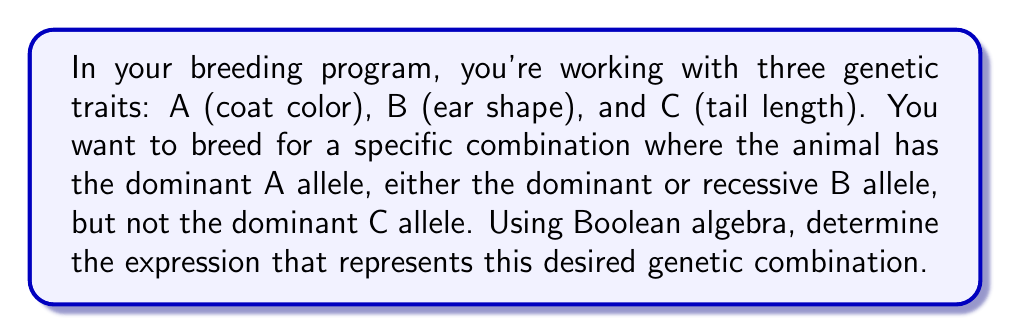Provide a solution to this math problem. Let's approach this step-by-step using Boolean algebra:

1) First, let's define our variables:
   $A$ = presence of dominant A allele
   $B$ = presence of dominant B allele
   $C$ = presence of dominant C allele

2) We want the dominant A allele, so we need $A$ to be true.

3) We want either the dominant or recessive B allele. In Boolean terms, this means we don't care about B, so it can be either true or false. We can represent this as $B + \bar{B}$, which always evaluates to 1 (true).

4) We don't want the dominant C allele, so we need $\bar{C}$ (the complement of C) to be true.

5) Combining these conditions using AND operations:

   $A \cdot (B + \bar{B}) \cdot \bar{C}$

6) We can simplify this expression:
   $A \cdot (B + \bar{B}) \cdot \bar{C}$
   $= A \cdot 1 \cdot \bar{C}$ (since $B + \bar{B} = 1$)
   $= A \cdot \bar{C}$

Therefore, the Boolean expression representing the desired genetic combination is $A \cdot \bar{C}$.
Answer: $A \cdot \bar{C}$ 